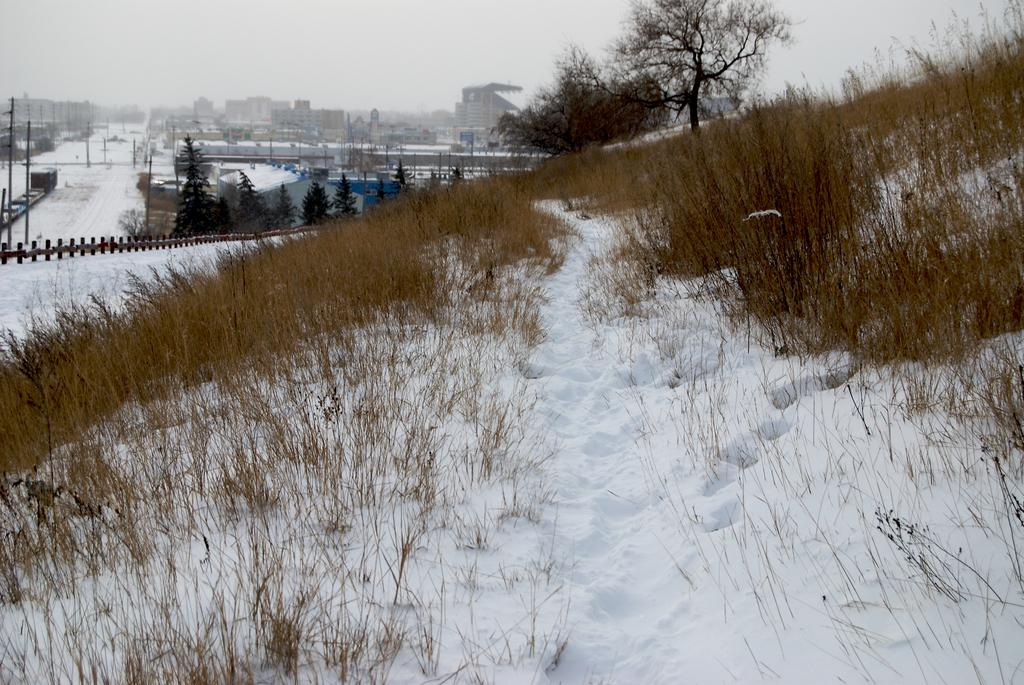What is the predominant color of the snow in the image? The snow in the image is white in color. What type of vegetation can be seen in the image? There is dry grass in the image. What natural elements are present in the image? There are trees in the image. What man-made structures are visible in the image? There is a building and a pole in the image. What architectural feature can be seen in the image? There is a fence in the image. What part of the natural environment is visible in the image? The sky is visible in the image. How many chickens are running around in the image? There are no chickens present in the image. What type of horses can be seen grazing in the image? There are no horses present in the image. 